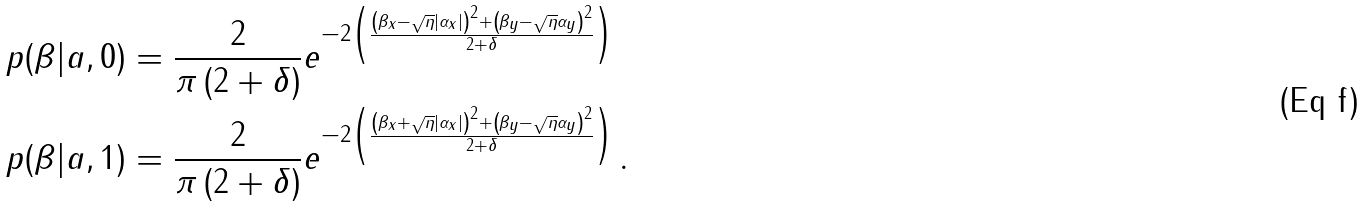Convert formula to latex. <formula><loc_0><loc_0><loc_500><loc_500>p ( \beta | a , 0 ) & = \frac { 2 } { \pi \left ( 2 + \delta \right ) } e ^ { - 2 \left ( \frac { \left ( \beta _ { x } - \sqrt { \eta } | \alpha _ { x } | \right ) ^ { 2 } + \left ( \beta _ { y } - \sqrt { \eta } \alpha _ { y } \right ) ^ { 2 } } { 2 + \delta } \right ) } \\ p ( \beta | a , 1 ) & = \frac { 2 } { \pi \left ( 2 + \delta \right ) } e ^ { - 2 \left ( \frac { \left ( \beta _ { x } + \sqrt { \eta } | \alpha _ { x } | \right ) ^ { 2 } + \left ( \beta _ { y } - \sqrt { \eta } \alpha _ { y } \right ) ^ { 2 } } { 2 + \delta } \right ) } \, .</formula> 